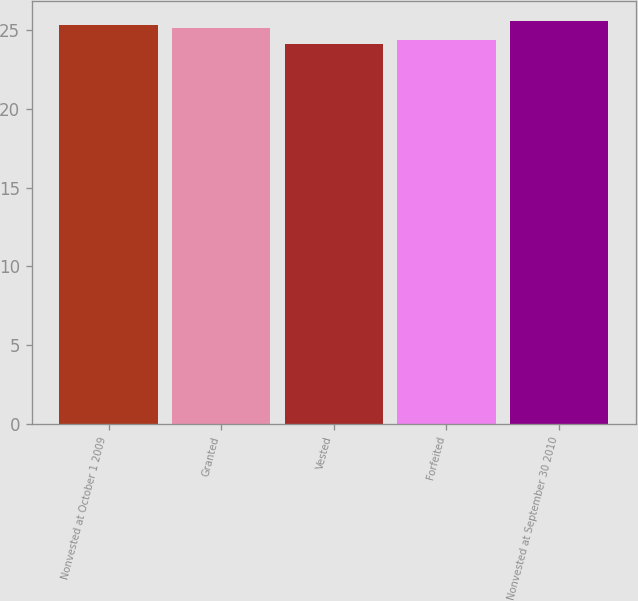Convert chart to OTSL. <chart><loc_0><loc_0><loc_500><loc_500><bar_chart><fcel>Nonvested at October 1 2009<fcel>Granted<fcel>Vested<fcel>Forfeited<fcel>Nonvested at September 30 2010<nl><fcel>25.32<fcel>25.17<fcel>24.1<fcel>24.38<fcel>25.58<nl></chart> 